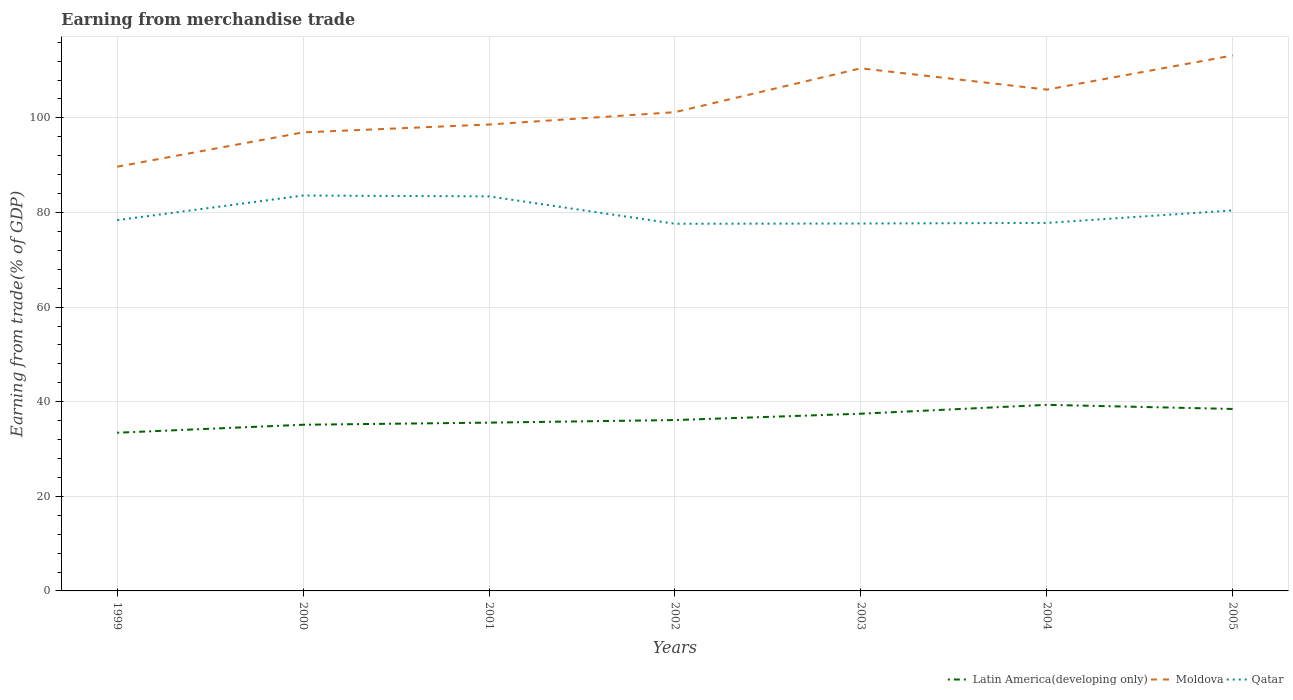How many different coloured lines are there?
Ensure brevity in your answer.  3. Does the line corresponding to Moldova intersect with the line corresponding to Latin America(developing only)?
Your response must be concise. No. Is the number of lines equal to the number of legend labels?
Your response must be concise. Yes. Across all years, what is the maximum earnings from trade in Latin America(developing only)?
Provide a succinct answer. 33.44. In which year was the earnings from trade in Moldova maximum?
Provide a short and direct response. 1999. What is the total earnings from trade in Moldova in the graph?
Your answer should be compact. -14.6. What is the difference between the highest and the second highest earnings from trade in Qatar?
Your response must be concise. 5.97. Is the earnings from trade in Qatar strictly greater than the earnings from trade in Latin America(developing only) over the years?
Ensure brevity in your answer.  No. How many lines are there?
Give a very brief answer. 3. How many years are there in the graph?
Provide a succinct answer. 7. What is the difference between two consecutive major ticks on the Y-axis?
Provide a succinct answer. 20. Are the values on the major ticks of Y-axis written in scientific E-notation?
Provide a succinct answer. No. Does the graph contain any zero values?
Give a very brief answer. No. Where does the legend appear in the graph?
Ensure brevity in your answer.  Bottom right. How are the legend labels stacked?
Give a very brief answer. Horizontal. What is the title of the graph?
Keep it short and to the point. Earning from merchandise trade. What is the label or title of the X-axis?
Offer a very short reply. Years. What is the label or title of the Y-axis?
Give a very brief answer. Earning from trade(% of GDP). What is the Earning from trade(% of GDP) in Latin America(developing only) in 1999?
Ensure brevity in your answer.  33.44. What is the Earning from trade(% of GDP) in Moldova in 1999?
Your answer should be very brief. 89.68. What is the Earning from trade(% of GDP) in Qatar in 1999?
Ensure brevity in your answer.  78.38. What is the Earning from trade(% of GDP) in Latin America(developing only) in 2000?
Your response must be concise. 35.13. What is the Earning from trade(% of GDP) in Moldova in 2000?
Offer a terse response. 96.94. What is the Earning from trade(% of GDP) in Qatar in 2000?
Offer a very short reply. 83.59. What is the Earning from trade(% of GDP) of Latin America(developing only) in 2001?
Offer a very short reply. 35.58. What is the Earning from trade(% of GDP) in Moldova in 2001?
Your answer should be very brief. 98.6. What is the Earning from trade(% of GDP) in Qatar in 2001?
Your answer should be very brief. 83.41. What is the Earning from trade(% of GDP) of Latin America(developing only) in 2002?
Your answer should be very brief. 36.12. What is the Earning from trade(% of GDP) of Moldova in 2002?
Your answer should be very brief. 101.21. What is the Earning from trade(% of GDP) of Qatar in 2002?
Make the answer very short. 77.62. What is the Earning from trade(% of GDP) in Latin America(developing only) in 2003?
Offer a terse response. 37.46. What is the Earning from trade(% of GDP) in Moldova in 2003?
Make the answer very short. 110.48. What is the Earning from trade(% of GDP) in Qatar in 2003?
Your answer should be compact. 77.67. What is the Earning from trade(% of GDP) of Latin America(developing only) in 2004?
Offer a terse response. 39.34. What is the Earning from trade(% of GDP) of Moldova in 2004?
Make the answer very short. 105.98. What is the Earning from trade(% of GDP) in Qatar in 2004?
Ensure brevity in your answer.  77.8. What is the Earning from trade(% of GDP) in Latin America(developing only) in 2005?
Give a very brief answer. 38.47. What is the Earning from trade(% of GDP) in Moldova in 2005?
Your response must be concise. 113.21. What is the Earning from trade(% of GDP) in Qatar in 2005?
Offer a terse response. 80.45. Across all years, what is the maximum Earning from trade(% of GDP) in Latin America(developing only)?
Make the answer very short. 39.34. Across all years, what is the maximum Earning from trade(% of GDP) of Moldova?
Make the answer very short. 113.21. Across all years, what is the maximum Earning from trade(% of GDP) in Qatar?
Offer a terse response. 83.59. Across all years, what is the minimum Earning from trade(% of GDP) in Latin America(developing only)?
Offer a very short reply. 33.44. Across all years, what is the minimum Earning from trade(% of GDP) of Moldova?
Ensure brevity in your answer.  89.68. Across all years, what is the minimum Earning from trade(% of GDP) of Qatar?
Make the answer very short. 77.62. What is the total Earning from trade(% of GDP) of Latin America(developing only) in the graph?
Make the answer very short. 255.55. What is the total Earning from trade(% of GDP) in Moldova in the graph?
Your answer should be compact. 716.12. What is the total Earning from trade(% of GDP) in Qatar in the graph?
Your answer should be compact. 558.92. What is the difference between the Earning from trade(% of GDP) in Latin America(developing only) in 1999 and that in 2000?
Make the answer very short. -1.69. What is the difference between the Earning from trade(% of GDP) in Moldova in 1999 and that in 2000?
Make the answer very short. -7.26. What is the difference between the Earning from trade(% of GDP) of Qatar in 1999 and that in 2000?
Keep it short and to the point. -5.21. What is the difference between the Earning from trade(% of GDP) in Latin America(developing only) in 1999 and that in 2001?
Ensure brevity in your answer.  -2.13. What is the difference between the Earning from trade(% of GDP) of Moldova in 1999 and that in 2001?
Your answer should be very brief. -8.92. What is the difference between the Earning from trade(% of GDP) in Qatar in 1999 and that in 2001?
Make the answer very short. -5.03. What is the difference between the Earning from trade(% of GDP) in Latin America(developing only) in 1999 and that in 2002?
Provide a short and direct response. -2.68. What is the difference between the Earning from trade(% of GDP) of Moldova in 1999 and that in 2002?
Keep it short and to the point. -11.53. What is the difference between the Earning from trade(% of GDP) of Qatar in 1999 and that in 2002?
Provide a short and direct response. 0.76. What is the difference between the Earning from trade(% of GDP) of Latin America(developing only) in 1999 and that in 2003?
Keep it short and to the point. -4.02. What is the difference between the Earning from trade(% of GDP) in Moldova in 1999 and that in 2003?
Offer a terse response. -20.8. What is the difference between the Earning from trade(% of GDP) in Qatar in 1999 and that in 2003?
Offer a terse response. 0.71. What is the difference between the Earning from trade(% of GDP) of Latin America(developing only) in 1999 and that in 2004?
Provide a succinct answer. -5.9. What is the difference between the Earning from trade(% of GDP) in Moldova in 1999 and that in 2004?
Ensure brevity in your answer.  -16.3. What is the difference between the Earning from trade(% of GDP) of Qatar in 1999 and that in 2004?
Offer a very short reply. 0.58. What is the difference between the Earning from trade(% of GDP) of Latin America(developing only) in 1999 and that in 2005?
Ensure brevity in your answer.  -5.02. What is the difference between the Earning from trade(% of GDP) of Moldova in 1999 and that in 2005?
Your answer should be compact. -23.52. What is the difference between the Earning from trade(% of GDP) of Qatar in 1999 and that in 2005?
Offer a terse response. -2.06. What is the difference between the Earning from trade(% of GDP) in Latin America(developing only) in 2000 and that in 2001?
Offer a terse response. -0.45. What is the difference between the Earning from trade(% of GDP) of Moldova in 2000 and that in 2001?
Offer a very short reply. -1.66. What is the difference between the Earning from trade(% of GDP) in Qatar in 2000 and that in 2001?
Your answer should be very brief. 0.18. What is the difference between the Earning from trade(% of GDP) of Latin America(developing only) in 2000 and that in 2002?
Your answer should be very brief. -0.99. What is the difference between the Earning from trade(% of GDP) of Moldova in 2000 and that in 2002?
Offer a terse response. -4.27. What is the difference between the Earning from trade(% of GDP) of Qatar in 2000 and that in 2002?
Your answer should be very brief. 5.97. What is the difference between the Earning from trade(% of GDP) of Latin America(developing only) in 2000 and that in 2003?
Provide a succinct answer. -2.33. What is the difference between the Earning from trade(% of GDP) in Moldova in 2000 and that in 2003?
Offer a terse response. -13.54. What is the difference between the Earning from trade(% of GDP) in Qatar in 2000 and that in 2003?
Your answer should be very brief. 5.92. What is the difference between the Earning from trade(% of GDP) of Latin America(developing only) in 2000 and that in 2004?
Provide a short and direct response. -4.21. What is the difference between the Earning from trade(% of GDP) of Moldova in 2000 and that in 2004?
Your response must be concise. -9.04. What is the difference between the Earning from trade(% of GDP) in Qatar in 2000 and that in 2004?
Provide a short and direct response. 5.79. What is the difference between the Earning from trade(% of GDP) in Latin America(developing only) in 2000 and that in 2005?
Give a very brief answer. -3.34. What is the difference between the Earning from trade(% of GDP) in Moldova in 2000 and that in 2005?
Your response must be concise. -16.27. What is the difference between the Earning from trade(% of GDP) of Qatar in 2000 and that in 2005?
Give a very brief answer. 3.15. What is the difference between the Earning from trade(% of GDP) in Latin America(developing only) in 2001 and that in 2002?
Your response must be concise. -0.55. What is the difference between the Earning from trade(% of GDP) of Moldova in 2001 and that in 2002?
Provide a succinct answer. -2.61. What is the difference between the Earning from trade(% of GDP) of Qatar in 2001 and that in 2002?
Your answer should be very brief. 5.79. What is the difference between the Earning from trade(% of GDP) in Latin America(developing only) in 2001 and that in 2003?
Your answer should be very brief. -1.88. What is the difference between the Earning from trade(% of GDP) in Moldova in 2001 and that in 2003?
Your response must be concise. -11.88. What is the difference between the Earning from trade(% of GDP) in Qatar in 2001 and that in 2003?
Keep it short and to the point. 5.74. What is the difference between the Earning from trade(% of GDP) of Latin America(developing only) in 2001 and that in 2004?
Make the answer very short. -3.76. What is the difference between the Earning from trade(% of GDP) of Moldova in 2001 and that in 2004?
Offer a very short reply. -7.38. What is the difference between the Earning from trade(% of GDP) in Qatar in 2001 and that in 2004?
Your response must be concise. 5.61. What is the difference between the Earning from trade(% of GDP) of Latin America(developing only) in 2001 and that in 2005?
Give a very brief answer. -2.89. What is the difference between the Earning from trade(% of GDP) in Moldova in 2001 and that in 2005?
Offer a very short reply. -14.6. What is the difference between the Earning from trade(% of GDP) in Qatar in 2001 and that in 2005?
Keep it short and to the point. 2.96. What is the difference between the Earning from trade(% of GDP) in Latin America(developing only) in 2002 and that in 2003?
Your answer should be compact. -1.34. What is the difference between the Earning from trade(% of GDP) of Moldova in 2002 and that in 2003?
Your answer should be compact. -9.27. What is the difference between the Earning from trade(% of GDP) of Qatar in 2002 and that in 2003?
Keep it short and to the point. -0.05. What is the difference between the Earning from trade(% of GDP) of Latin America(developing only) in 2002 and that in 2004?
Make the answer very short. -3.22. What is the difference between the Earning from trade(% of GDP) in Moldova in 2002 and that in 2004?
Ensure brevity in your answer.  -4.77. What is the difference between the Earning from trade(% of GDP) of Qatar in 2002 and that in 2004?
Your answer should be very brief. -0.18. What is the difference between the Earning from trade(% of GDP) in Latin America(developing only) in 2002 and that in 2005?
Offer a terse response. -2.35. What is the difference between the Earning from trade(% of GDP) of Moldova in 2002 and that in 2005?
Your answer should be very brief. -11.99. What is the difference between the Earning from trade(% of GDP) in Qatar in 2002 and that in 2005?
Ensure brevity in your answer.  -2.83. What is the difference between the Earning from trade(% of GDP) of Latin America(developing only) in 2003 and that in 2004?
Your answer should be compact. -1.88. What is the difference between the Earning from trade(% of GDP) in Moldova in 2003 and that in 2004?
Provide a short and direct response. 4.5. What is the difference between the Earning from trade(% of GDP) in Qatar in 2003 and that in 2004?
Your answer should be very brief. -0.13. What is the difference between the Earning from trade(% of GDP) of Latin America(developing only) in 2003 and that in 2005?
Offer a very short reply. -1.01. What is the difference between the Earning from trade(% of GDP) of Moldova in 2003 and that in 2005?
Make the answer very short. -2.72. What is the difference between the Earning from trade(% of GDP) in Qatar in 2003 and that in 2005?
Your answer should be compact. -2.77. What is the difference between the Earning from trade(% of GDP) in Latin America(developing only) in 2004 and that in 2005?
Provide a short and direct response. 0.87. What is the difference between the Earning from trade(% of GDP) in Moldova in 2004 and that in 2005?
Offer a terse response. -7.22. What is the difference between the Earning from trade(% of GDP) of Qatar in 2004 and that in 2005?
Make the answer very short. -2.65. What is the difference between the Earning from trade(% of GDP) of Latin America(developing only) in 1999 and the Earning from trade(% of GDP) of Moldova in 2000?
Provide a short and direct response. -63.5. What is the difference between the Earning from trade(% of GDP) in Latin America(developing only) in 1999 and the Earning from trade(% of GDP) in Qatar in 2000?
Your response must be concise. -50.15. What is the difference between the Earning from trade(% of GDP) of Moldova in 1999 and the Earning from trade(% of GDP) of Qatar in 2000?
Your response must be concise. 6.09. What is the difference between the Earning from trade(% of GDP) of Latin America(developing only) in 1999 and the Earning from trade(% of GDP) of Moldova in 2001?
Keep it short and to the point. -65.16. What is the difference between the Earning from trade(% of GDP) in Latin America(developing only) in 1999 and the Earning from trade(% of GDP) in Qatar in 2001?
Ensure brevity in your answer.  -49.97. What is the difference between the Earning from trade(% of GDP) of Moldova in 1999 and the Earning from trade(% of GDP) of Qatar in 2001?
Keep it short and to the point. 6.27. What is the difference between the Earning from trade(% of GDP) of Latin America(developing only) in 1999 and the Earning from trade(% of GDP) of Moldova in 2002?
Provide a succinct answer. -67.77. What is the difference between the Earning from trade(% of GDP) in Latin America(developing only) in 1999 and the Earning from trade(% of GDP) in Qatar in 2002?
Offer a very short reply. -44.17. What is the difference between the Earning from trade(% of GDP) of Moldova in 1999 and the Earning from trade(% of GDP) of Qatar in 2002?
Ensure brevity in your answer.  12.06. What is the difference between the Earning from trade(% of GDP) in Latin America(developing only) in 1999 and the Earning from trade(% of GDP) in Moldova in 2003?
Provide a short and direct response. -77.04. What is the difference between the Earning from trade(% of GDP) in Latin America(developing only) in 1999 and the Earning from trade(% of GDP) in Qatar in 2003?
Give a very brief answer. -44.23. What is the difference between the Earning from trade(% of GDP) in Moldova in 1999 and the Earning from trade(% of GDP) in Qatar in 2003?
Your answer should be very brief. 12.01. What is the difference between the Earning from trade(% of GDP) of Latin America(developing only) in 1999 and the Earning from trade(% of GDP) of Moldova in 2004?
Ensure brevity in your answer.  -72.54. What is the difference between the Earning from trade(% of GDP) of Latin America(developing only) in 1999 and the Earning from trade(% of GDP) of Qatar in 2004?
Your answer should be very brief. -44.35. What is the difference between the Earning from trade(% of GDP) in Moldova in 1999 and the Earning from trade(% of GDP) in Qatar in 2004?
Give a very brief answer. 11.89. What is the difference between the Earning from trade(% of GDP) of Latin America(developing only) in 1999 and the Earning from trade(% of GDP) of Moldova in 2005?
Provide a short and direct response. -79.76. What is the difference between the Earning from trade(% of GDP) of Latin America(developing only) in 1999 and the Earning from trade(% of GDP) of Qatar in 2005?
Your response must be concise. -47. What is the difference between the Earning from trade(% of GDP) in Moldova in 1999 and the Earning from trade(% of GDP) in Qatar in 2005?
Offer a terse response. 9.24. What is the difference between the Earning from trade(% of GDP) in Latin America(developing only) in 2000 and the Earning from trade(% of GDP) in Moldova in 2001?
Give a very brief answer. -63.47. What is the difference between the Earning from trade(% of GDP) of Latin America(developing only) in 2000 and the Earning from trade(% of GDP) of Qatar in 2001?
Keep it short and to the point. -48.28. What is the difference between the Earning from trade(% of GDP) of Moldova in 2000 and the Earning from trade(% of GDP) of Qatar in 2001?
Offer a very short reply. 13.53. What is the difference between the Earning from trade(% of GDP) in Latin America(developing only) in 2000 and the Earning from trade(% of GDP) in Moldova in 2002?
Your response must be concise. -66.08. What is the difference between the Earning from trade(% of GDP) of Latin America(developing only) in 2000 and the Earning from trade(% of GDP) of Qatar in 2002?
Provide a short and direct response. -42.49. What is the difference between the Earning from trade(% of GDP) of Moldova in 2000 and the Earning from trade(% of GDP) of Qatar in 2002?
Your response must be concise. 19.32. What is the difference between the Earning from trade(% of GDP) of Latin America(developing only) in 2000 and the Earning from trade(% of GDP) of Moldova in 2003?
Your answer should be very brief. -75.35. What is the difference between the Earning from trade(% of GDP) in Latin America(developing only) in 2000 and the Earning from trade(% of GDP) in Qatar in 2003?
Provide a succinct answer. -42.54. What is the difference between the Earning from trade(% of GDP) of Moldova in 2000 and the Earning from trade(% of GDP) of Qatar in 2003?
Ensure brevity in your answer.  19.27. What is the difference between the Earning from trade(% of GDP) in Latin America(developing only) in 2000 and the Earning from trade(% of GDP) in Moldova in 2004?
Keep it short and to the point. -70.85. What is the difference between the Earning from trade(% of GDP) of Latin America(developing only) in 2000 and the Earning from trade(% of GDP) of Qatar in 2004?
Your response must be concise. -42.67. What is the difference between the Earning from trade(% of GDP) in Moldova in 2000 and the Earning from trade(% of GDP) in Qatar in 2004?
Provide a short and direct response. 19.14. What is the difference between the Earning from trade(% of GDP) in Latin America(developing only) in 2000 and the Earning from trade(% of GDP) in Moldova in 2005?
Offer a very short reply. -78.08. What is the difference between the Earning from trade(% of GDP) in Latin America(developing only) in 2000 and the Earning from trade(% of GDP) in Qatar in 2005?
Give a very brief answer. -45.32. What is the difference between the Earning from trade(% of GDP) in Moldova in 2000 and the Earning from trade(% of GDP) in Qatar in 2005?
Your response must be concise. 16.49. What is the difference between the Earning from trade(% of GDP) in Latin America(developing only) in 2001 and the Earning from trade(% of GDP) in Moldova in 2002?
Make the answer very short. -65.64. What is the difference between the Earning from trade(% of GDP) in Latin America(developing only) in 2001 and the Earning from trade(% of GDP) in Qatar in 2002?
Offer a terse response. -42.04. What is the difference between the Earning from trade(% of GDP) in Moldova in 2001 and the Earning from trade(% of GDP) in Qatar in 2002?
Make the answer very short. 20.99. What is the difference between the Earning from trade(% of GDP) in Latin America(developing only) in 2001 and the Earning from trade(% of GDP) in Moldova in 2003?
Keep it short and to the point. -74.91. What is the difference between the Earning from trade(% of GDP) in Latin America(developing only) in 2001 and the Earning from trade(% of GDP) in Qatar in 2003?
Offer a very short reply. -42.1. What is the difference between the Earning from trade(% of GDP) of Moldova in 2001 and the Earning from trade(% of GDP) of Qatar in 2003?
Give a very brief answer. 20.93. What is the difference between the Earning from trade(% of GDP) in Latin America(developing only) in 2001 and the Earning from trade(% of GDP) in Moldova in 2004?
Your response must be concise. -70.41. What is the difference between the Earning from trade(% of GDP) of Latin America(developing only) in 2001 and the Earning from trade(% of GDP) of Qatar in 2004?
Your answer should be compact. -42.22. What is the difference between the Earning from trade(% of GDP) of Moldova in 2001 and the Earning from trade(% of GDP) of Qatar in 2004?
Offer a terse response. 20.81. What is the difference between the Earning from trade(% of GDP) of Latin America(developing only) in 2001 and the Earning from trade(% of GDP) of Moldova in 2005?
Provide a succinct answer. -77.63. What is the difference between the Earning from trade(% of GDP) in Latin America(developing only) in 2001 and the Earning from trade(% of GDP) in Qatar in 2005?
Offer a terse response. -44.87. What is the difference between the Earning from trade(% of GDP) in Moldova in 2001 and the Earning from trade(% of GDP) in Qatar in 2005?
Provide a succinct answer. 18.16. What is the difference between the Earning from trade(% of GDP) of Latin America(developing only) in 2002 and the Earning from trade(% of GDP) of Moldova in 2003?
Offer a very short reply. -74.36. What is the difference between the Earning from trade(% of GDP) in Latin America(developing only) in 2002 and the Earning from trade(% of GDP) in Qatar in 2003?
Your answer should be very brief. -41.55. What is the difference between the Earning from trade(% of GDP) in Moldova in 2002 and the Earning from trade(% of GDP) in Qatar in 2003?
Your answer should be very brief. 23.54. What is the difference between the Earning from trade(% of GDP) of Latin America(developing only) in 2002 and the Earning from trade(% of GDP) of Moldova in 2004?
Give a very brief answer. -69.86. What is the difference between the Earning from trade(% of GDP) of Latin America(developing only) in 2002 and the Earning from trade(% of GDP) of Qatar in 2004?
Offer a very short reply. -41.68. What is the difference between the Earning from trade(% of GDP) in Moldova in 2002 and the Earning from trade(% of GDP) in Qatar in 2004?
Give a very brief answer. 23.42. What is the difference between the Earning from trade(% of GDP) of Latin America(developing only) in 2002 and the Earning from trade(% of GDP) of Moldova in 2005?
Your answer should be compact. -77.08. What is the difference between the Earning from trade(% of GDP) in Latin America(developing only) in 2002 and the Earning from trade(% of GDP) in Qatar in 2005?
Offer a very short reply. -44.32. What is the difference between the Earning from trade(% of GDP) of Moldova in 2002 and the Earning from trade(% of GDP) of Qatar in 2005?
Offer a very short reply. 20.77. What is the difference between the Earning from trade(% of GDP) of Latin America(developing only) in 2003 and the Earning from trade(% of GDP) of Moldova in 2004?
Make the answer very short. -68.52. What is the difference between the Earning from trade(% of GDP) in Latin America(developing only) in 2003 and the Earning from trade(% of GDP) in Qatar in 2004?
Offer a very short reply. -40.34. What is the difference between the Earning from trade(% of GDP) of Moldova in 2003 and the Earning from trade(% of GDP) of Qatar in 2004?
Give a very brief answer. 32.69. What is the difference between the Earning from trade(% of GDP) in Latin America(developing only) in 2003 and the Earning from trade(% of GDP) in Moldova in 2005?
Ensure brevity in your answer.  -75.74. What is the difference between the Earning from trade(% of GDP) in Latin America(developing only) in 2003 and the Earning from trade(% of GDP) in Qatar in 2005?
Offer a very short reply. -42.98. What is the difference between the Earning from trade(% of GDP) in Moldova in 2003 and the Earning from trade(% of GDP) in Qatar in 2005?
Your answer should be very brief. 30.04. What is the difference between the Earning from trade(% of GDP) in Latin America(developing only) in 2004 and the Earning from trade(% of GDP) in Moldova in 2005?
Give a very brief answer. -73.87. What is the difference between the Earning from trade(% of GDP) of Latin America(developing only) in 2004 and the Earning from trade(% of GDP) of Qatar in 2005?
Your response must be concise. -41.11. What is the difference between the Earning from trade(% of GDP) of Moldova in 2004 and the Earning from trade(% of GDP) of Qatar in 2005?
Provide a short and direct response. 25.54. What is the average Earning from trade(% of GDP) of Latin America(developing only) per year?
Offer a terse response. 36.51. What is the average Earning from trade(% of GDP) in Moldova per year?
Offer a terse response. 102.3. What is the average Earning from trade(% of GDP) of Qatar per year?
Ensure brevity in your answer.  79.85. In the year 1999, what is the difference between the Earning from trade(% of GDP) of Latin America(developing only) and Earning from trade(% of GDP) of Moldova?
Offer a very short reply. -56.24. In the year 1999, what is the difference between the Earning from trade(% of GDP) of Latin America(developing only) and Earning from trade(% of GDP) of Qatar?
Your response must be concise. -44.94. In the year 1999, what is the difference between the Earning from trade(% of GDP) in Moldova and Earning from trade(% of GDP) in Qatar?
Offer a terse response. 11.3. In the year 2000, what is the difference between the Earning from trade(% of GDP) in Latin America(developing only) and Earning from trade(% of GDP) in Moldova?
Your answer should be very brief. -61.81. In the year 2000, what is the difference between the Earning from trade(% of GDP) of Latin America(developing only) and Earning from trade(% of GDP) of Qatar?
Provide a succinct answer. -48.46. In the year 2000, what is the difference between the Earning from trade(% of GDP) of Moldova and Earning from trade(% of GDP) of Qatar?
Your response must be concise. 13.35. In the year 2001, what is the difference between the Earning from trade(% of GDP) in Latin America(developing only) and Earning from trade(% of GDP) in Moldova?
Your answer should be compact. -63.03. In the year 2001, what is the difference between the Earning from trade(% of GDP) of Latin America(developing only) and Earning from trade(% of GDP) of Qatar?
Offer a terse response. -47.83. In the year 2001, what is the difference between the Earning from trade(% of GDP) of Moldova and Earning from trade(% of GDP) of Qatar?
Provide a succinct answer. 15.19. In the year 2002, what is the difference between the Earning from trade(% of GDP) of Latin America(developing only) and Earning from trade(% of GDP) of Moldova?
Offer a terse response. -65.09. In the year 2002, what is the difference between the Earning from trade(% of GDP) of Latin America(developing only) and Earning from trade(% of GDP) of Qatar?
Offer a very short reply. -41.5. In the year 2002, what is the difference between the Earning from trade(% of GDP) in Moldova and Earning from trade(% of GDP) in Qatar?
Provide a succinct answer. 23.59. In the year 2003, what is the difference between the Earning from trade(% of GDP) in Latin America(developing only) and Earning from trade(% of GDP) in Moldova?
Your answer should be compact. -73.02. In the year 2003, what is the difference between the Earning from trade(% of GDP) in Latin America(developing only) and Earning from trade(% of GDP) in Qatar?
Give a very brief answer. -40.21. In the year 2003, what is the difference between the Earning from trade(% of GDP) of Moldova and Earning from trade(% of GDP) of Qatar?
Provide a succinct answer. 32.81. In the year 2004, what is the difference between the Earning from trade(% of GDP) in Latin America(developing only) and Earning from trade(% of GDP) in Moldova?
Give a very brief answer. -66.64. In the year 2004, what is the difference between the Earning from trade(% of GDP) in Latin America(developing only) and Earning from trade(% of GDP) in Qatar?
Make the answer very short. -38.46. In the year 2004, what is the difference between the Earning from trade(% of GDP) of Moldova and Earning from trade(% of GDP) of Qatar?
Offer a terse response. 28.19. In the year 2005, what is the difference between the Earning from trade(% of GDP) of Latin America(developing only) and Earning from trade(% of GDP) of Moldova?
Ensure brevity in your answer.  -74.74. In the year 2005, what is the difference between the Earning from trade(% of GDP) of Latin America(developing only) and Earning from trade(% of GDP) of Qatar?
Make the answer very short. -41.98. In the year 2005, what is the difference between the Earning from trade(% of GDP) in Moldova and Earning from trade(% of GDP) in Qatar?
Ensure brevity in your answer.  32.76. What is the ratio of the Earning from trade(% of GDP) of Moldova in 1999 to that in 2000?
Give a very brief answer. 0.93. What is the ratio of the Earning from trade(% of GDP) in Qatar in 1999 to that in 2000?
Your response must be concise. 0.94. What is the ratio of the Earning from trade(% of GDP) of Latin America(developing only) in 1999 to that in 2001?
Keep it short and to the point. 0.94. What is the ratio of the Earning from trade(% of GDP) of Moldova in 1999 to that in 2001?
Ensure brevity in your answer.  0.91. What is the ratio of the Earning from trade(% of GDP) in Qatar in 1999 to that in 2001?
Provide a short and direct response. 0.94. What is the ratio of the Earning from trade(% of GDP) of Latin America(developing only) in 1999 to that in 2002?
Your answer should be very brief. 0.93. What is the ratio of the Earning from trade(% of GDP) of Moldova in 1999 to that in 2002?
Make the answer very short. 0.89. What is the ratio of the Earning from trade(% of GDP) in Qatar in 1999 to that in 2002?
Keep it short and to the point. 1.01. What is the ratio of the Earning from trade(% of GDP) in Latin America(developing only) in 1999 to that in 2003?
Offer a terse response. 0.89. What is the ratio of the Earning from trade(% of GDP) of Moldova in 1999 to that in 2003?
Offer a terse response. 0.81. What is the ratio of the Earning from trade(% of GDP) of Qatar in 1999 to that in 2003?
Your response must be concise. 1.01. What is the ratio of the Earning from trade(% of GDP) in Latin America(developing only) in 1999 to that in 2004?
Make the answer very short. 0.85. What is the ratio of the Earning from trade(% of GDP) in Moldova in 1999 to that in 2004?
Provide a succinct answer. 0.85. What is the ratio of the Earning from trade(% of GDP) of Qatar in 1999 to that in 2004?
Offer a terse response. 1.01. What is the ratio of the Earning from trade(% of GDP) of Latin America(developing only) in 1999 to that in 2005?
Offer a very short reply. 0.87. What is the ratio of the Earning from trade(% of GDP) in Moldova in 1999 to that in 2005?
Give a very brief answer. 0.79. What is the ratio of the Earning from trade(% of GDP) in Qatar in 1999 to that in 2005?
Provide a succinct answer. 0.97. What is the ratio of the Earning from trade(% of GDP) of Latin America(developing only) in 2000 to that in 2001?
Your response must be concise. 0.99. What is the ratio of the Earning from trade(% of GDP) in Moldova in 2000 to that in 2001?
Make the answer very short. 0.98. What is the ratio of the Earning from trade(% of GDP) of Qatar in 2000 to that in 2001?
Provide a succinct answer. 1. What is the ratio of the Earning from trade(% of GDP) in Latin America(developing only) in 2000 to that in 2002?
Offer a very short reply. 0.97. What is the ratio of the Earning from trade(% of GDP) in Moldova in 2000 to that in 2002?
Your answer should be compact. 0.96. What is the ratio of the Earning from trade(% of GDP) in Qatar in 2000 to that in 2002?
Provide a short and direct response. 1.08. What is the ratio of the Earning from trade(% of GDP) of Latin America(developing only) in 2000 to that in 2003?
Your response must be concise. 0.94. What is the ratio of the Earning from trade(% of GDP) in Moldova in 2000 to that in 2003?
Keep it short and to the point. 0.88. What is the ratio of the Earning from trade(% of GDP) in Qatar in 2000 to that in 2003?
Keep it short and to the point. 1.08. What is the ratio of the Earning from trade(% of GDP) in Latin America(developing only) in 2000 to that in 2004?
Provide a succinct answer. 0.89. What is the ratio of the Earning from trade(% of GDP) of Moldova in 2000 to that in 2004?
Give a very brief answer. 0.91. What is the ratio of the Earning from trade(% of GDP) of Qatar in 2000 to that in 2004?
Give a very brief answer. 1.07. What is the ratio of the Earning from trade(% of GDP) of Latin America(developing only) in 2000 to that in 2005?
Offer a very short reply. 0.91. What is the ratio of the Earning from trade(% of GDP) of Moldova in 2000 to that in 2005?
Provide a short and direct response. 0.86. What is the ratio of the Earning from trade(% of GDP) of Qatar in 2000 to that in 2005?
Give a very brief answer. 1.04. What is the ratio of the Earning from trade(% of GDP) of Latin America(developing only) in 2001 to that in 2002?
Your answer should be very brief. 0.98. What is the ratio of the Earning from trade(% of GDP) of Moldova in 2001 to that in 2002?
Provide a succinct answer. 0.97. What is the ratio of the Earning from trade(% of GDP) of Qatar in 2001 to that in 2002?
Provide a short and direct response. 1.07. What is the ratio of the Earning from trade(% of GDP) in Latin America(developing only) in 2001 to that in 2003?
Offer a very short reply. 0.95. What is the ratio of the Earning from trade(% of GDP) in Moldova in 2001 to that in 2003?
Provide a short and direct response. 0.89. What is the ratio of the Earning from trade(% of GDP) of Qatar in 2001 to that in 2003?
Your answer should be compact. 1.07. What is the ratio of the Earning from trade(% of GDP) in Latin America(developing only) in 2001 to that in 2004?
Provide a short and direct response. 0.9. What is the ratio of the Earning from trade(% of GDP) of Moldova in 2001 to that in 2004?
Your answer should be very brief. 0.93. What is the ratio of the Earning from trade(% of GDP) in Qatar in 2001 to that in 2004?
Your response must be concise. 1.07. What is the ratio of the Earning from trade(% of GDP) of Latin America(developing only) in 2001 to that in 2005?
Give a very brief answer. 0.92. What is the ratio of the Earning from trade(% of GDP) of Moldova in 2001 to that in 2005?
Your answer should be compact. 0.87. What is the ratio of the Earning from trade(% of GDP) in Qatar in 2001 to that in 2005?
Your response must be concise. 1.04. What is the ratio of the Earning from trade(% of GDP) of Latin America(developing only) in 2002 to that in 2003?
Your answer should be very brief. 0.96. What is the ratio of the Earning from trade(% of GDP) in Moldova in 2002 to that in 2003?
Your answer should be compact. 0.92. What is the ratio of the Earning from trade(% of GDP) in Latin America(developing only) in 2002 to that in 2004?
Ensure brevity in your answer.  0.92. What is the ratio of the Earning from trade(% of GDP) of Moldova in 2002 to that in 2004?
Make the answer very short. 0.95. What is the ratio of the Earning from trade(% of GDP) of Qatar in 2002 to that in 2004?
Offer a very short reply. 1. What is the ratio of the Earning from trade(% of GDP) in Latin America(developing only) in 2002 to that in 2005?
Offer a very short reply. 0.94. What is the ratio of the Earning from trade(% of GDP) in Moldova in 2002 to that in 2005?
Your answer should be very brief. 0.89. What is the ratio of the Earning from trade(% of GDP) of Qatar in 2002 to that in 2005?
Provide a short and direct response. 0.96. What is the ratio of the Earning from trade(% of GDP) of Latin America(developing only) in 2003 to that in 2004?
Keep it short and to the point. 0.95. What is the ratio of the Earning from trade(% of GDP) of Moldova in 2003 to that in 2004?
Ensure brevity in your answer.  1.04. What is the ratio of the Earning from trade(% of GDP) of Latin America(developing only) in 2003 to that in 2005?
Make the answer very short. 0.97. What is the ratio of the Earning from trade(% of GDP) of Moldova in 2003 to that in 2005?
Your response must be concise. 0.98. What is the ratio of the Earning from trade(% of GDP) of Qatar in 2003 to that in 2005?
Make the answer very short. 0.97. What is the ratio of the Earning from trade(% of GDP) of Latin America(developing only) in 2004 to that in 2005?
Provide a succinct answer. 1.02. What is the ratio of the Earning from trade(% of GDP) in Moldova in 2004 to that in 2005?
Your answer should be compact. 0.94. What is the ratio of the Earning from trade(% of GDP) of Qatar in 2004 to that in 2005?
Give a very brief answer. 0.97. What is the difference between the highest and the second highest Earning from trade(% of GDP) in Latin America(developing only)?
Keep it short and to the point. 0.87. What is the difference between the highest and the second highest Earning from trade(% of GDP) in Moldova?
Offer a very short reply. 2.72. What is the difference between the highest and the second highest Earning from trade(% of GDP) in Qatar?
Your response must be concise. 0.18. What is the difference between the highest and the lowest Earning from trade(% of GDP) in Latin America(developing only)?
Make the answer very short. 5.9. What is the difference between the highest and the lowest Earning from trade(% of GDP) in Moldova?
Offer a terse response. 23.52. What is the difference between the highest and the lowest Earning from trade(% of GDP) in Qatar?
Your answer should be very brief. 5.97. 